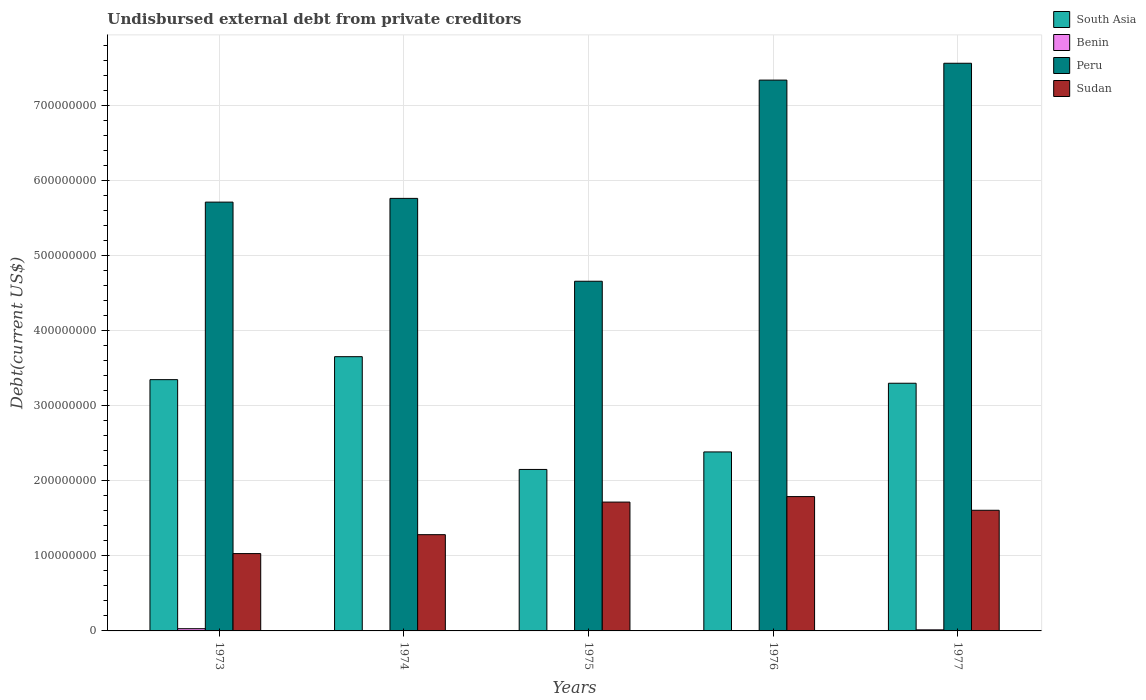How many different coloured bars are there?
Provide a succinct answer. 4. How many groups of bars are there?
Offer a very short reply. 5. What is the label of the 3rd group of bars from the left?
Ensure brevity in your answer.  1975. What is the total debt in Sudan in 1976?
Ensure brevity in your answer.  1.79e+08. Across all years, what is the maximum total debt in South Asia?
Provide a short and direct response. 3.65e+08. Across all years, what is the minimum total debt in Benin?
Provide a succinct answer. 4.31e+05. In which year was the total debt in South Asia maximum?
Make the answer very short. 1974. In which year was the total debt in Peru minimum?
Make the answer very short. 1975. What is the total total debt in Peru in the graph?
Make the answer very short. 3.10e+09. What is the difference between the total debt in Benin in 1974 and that in 1976?
Keep it short and to the point. 2000. What is the difference between the total debt in South Asia in 1975 and the total debt in Sudan in 1974?
Offer a very short reply. 8.69e+07. What is the average total debt in Benin per year?
Provide a short and direct response. 1.14e+06. In the year 1973, what is the difference between the total debt in Sudan and total debt in South Asia?
Provide a succinct answer. -2.32e+08. What is the ratio of the total debt in Sudan in 1973 to that in 1976?
Keep it short and to the point. 0.58. Is the difference between the total debt in Sudan in 1973 and 1974 greater than the difference between the total debt in South Asia in 1973 and 1974?
Offer a very short reply. Yes. What is the difference between the highest and the second highest total debt in Benin?
Provide a short and direct response. 1.53e+06. What is the difference between the highest and the lowest total debt in Benin?
Your response must be concise. 2.53e+06. In how many years, is the total debt in Sudan greater than the average total debt in Sudan taken over all years?
Give a very brief answer. 3. What does the 1st bar from the left in 1973 represents?
Give a very brief answer. South Asia. What does the 1st bar from the right in 1974 represents?
Provide a succinct answer. Sudan. Is it the case that in every year, the sum of the total debt in Sudan and total debt in South Asia is greater than the total debt in Peru?
Give a very brief answer. No. What is the difference between two consecutive major ticks on the Y-axis?
Offer a terse response. 1.00e+08. Are the values on the major ticks of Y-axis written in scientific E-notation?
Your answer should be compact. No. Does the graph contain grids?
Your response must be concise. Yes. Where does the legend appear in the graph?
Ensure brevity in your answer.  Top right. How are the legend labels stacked?
Offer a very short reply. Vertical. What is the title of the graph?
Make the answer very short. Undisbursed external debt from private creditors. Does "Zambia" appear as one of the legend labels in the graph?
Offer a terse response. No. What is the label or title of the Y-axis?
Offer a very short reply. Debt(current US$). What is the Debt(current US$) in South Asia in 1973?
Offer a terse response. 3.35e+08. What is the Debt(current US$) in Benin in 1973?
Offer a very short reply. 2.96e+06. What is the Debt(current US$) in Peru in 1973?
Your answer should be very brief. 5.71e+08. What is the Debt(current US$) in Sudan in 1973?
Ensure brevity in your answer.  1.03e+08. What is the Debt(current US$) of South Asia in 1974?
Offer a terse response. 3.65e+08. What is the Debt(current US$) of Benin in 1974?
Your answer should be very brief. 4.33e+05. What is the Debt(current US$) in Peru in 1974?
Your response must be concise. 5.76e+08. What is the Debt(current US$) in Sudan in 1974?
Provide a succinct answer. 1.28e+08. What is the Debt(current US$) in South Asia in 1975?
Offer a terse response. 2.15e+08. What is the Debt(current US$) of Benin in 1975?
Ensure brevity in your answer.  4.32e+05. What is the Debt(current US$) in Peru in 1975?
Your response must be concise. 4.66e+08. What is the Debt(current US$) of Sudan in 1975?
Offer a very short reply. 1.72e+08. What is the Debt(current US$) of South Asia in 1976?
Provide a short and direct response. 2.38e+08. What is the Debt(current US$) in Benin in 1976?
Provide a short and direct response. 4.31e+05. What is the Debt(current US$) in Peru in 1976?
Your answer should be very brief. 7.34e+08. What is the Debt(current US$) of Sudan in 1976?
Ensure brevity in your answer.  1.79e+08. What is the Debt(current US$) of South Asia in 1977?
Provide a short and direct response. 3.30e+08. What is the Debt(current US$) of Benin in 1977?
Your response must be concise. 1.43e+06. What is the Debt(current US$) of Peru in 1977?
Make the answer very short. 7.56e+08. What is the Debt(current US$) in Sudan in 1977?
Ensure brevity in your answer.  1.61e+08. Across all years, what is the maximum Debt(current US$) of South Asia?
Offer a very short reply. 3.65e+08. Across all years, what is the maximum Debt(current US$) of Benin?
Your response must be concise. 2.96e+06. Across all years, what is the maximum Debt(current US$) of Peru?
Make the answer very short. 7.56e+08. Across all years, what is the maximum Debt(current US$) in Sudan?
Keep it short and to the point. 1.79e+08. Across all years, what is the minimum Debt(current US$) of South Asia?
Offer a terse response. 2.15e+08. Across all years, what is the minimum Debt(current US$) of Benin?
Make the answer very short. 4.31e+05. Across all years, what is the minimum Debt(current US$) in Peru?
Ensure brevity in your answer.  4.66e+08. Across all years, what is the minimum Debt(current US$) in Sudan?
Ensure brevity in your answer.  1.03e+08. What is the total Debt(current US$) in South Asia in the graph?
Provide a succinct answer. 1.48e+09. What is the total Debt(current US$) in Benin in the graph?
Your answer should be compact. 5.69e+06. What is the total Debt(current US$) of Peru in the graph?
Your answer should be compact. 3.10e+09. What is the total Debt(current US$) of Sudan in the graph?
Ensure brevity in your answer.  7.43e+08. What is the difference between the Debt(current US$) of South Asia in 1973 and that in 1974?
Provide a short and direct response. -3.06e+07. What is the difference between the Debt(current US$) of Benin in 1973 and that in 1974?
Offer a very short reply. 2.52e+06. What is the difference between the Debt(current US$) in Peru in 1973 and that in 1974?
Offer a very short reply. -4.98e+06. What is the difference between the Debt(current US$) in Sudan in 1973 and that in 1974?
Provide a short and direct response. -2.52e+07. What is the difference between the Debt(current US$) of South Asia in 1973 and that in 1975?
Ensure brevity in your answer.  1.20e+08. What is the difference between the Debt(current US$) of Benin in 1973 and that in 1975?
Provide a short and direct response. 2.53e+06. What is the difference between the Debt(current US$) of Peru in 1973 and that in 1975?
Give a very brief answer. 1.05e+08. What is the difference between the Debt(current US$) in Sudan in 1973 and that in 1975?
Your response must be concise. -6.86e+07. What is the difference between the Debt(current US$) in South Asia in 1973 and that in 1976?
Offer a terse response. 9.63e+07. What is the difference between the Debt(current US$) of Benin in 1973 and that in 1976?
Give a very brief answer. 2.53e+06. What is the difference between the Debt(current US$) in Peru in 1973 and that in 1976?
Your response must be concise. -1.63e+08. What is the difference between the Debt(current US$) of Sudan in 1973 and that in 1976?
Offer a very short reply. -7.59e+07. What is the difference between the Debt(current US$) in South Asia in 1973 and that in 1977?
Make the answer very short. 4.78e+06. What is the difference between the Debt(current US$) of Benin in 1973 and that in 1977?
Your response must be concise. 1.53e+06. What is the difference between the Debt(current US$) in Peru in 1973 and that in 1977?
Keep it short and to the point. -1.85e+08. What is the difference between the Debt(current US$) of Sudan in 1973 and that in 1977?
Provide a succinct answer. -5.77e+07. What is the difference between the Debt(current US$) of South Asia in 1974 and that in 1975?
Ensure brevity in your answer.  1.50e+08. What is the difference between the Debt(current US$) in Peru in 1974 and that in 1975?
Provide a short and direct response. 1.10e+08. What is the difference between the Debt(current US$) of Sudan in 1974 and that in 1975?
Provide a short and direct response. -4.34e+07. What is the difference between the Debt(current US$) in South Asia in 1974 and that in 1976?
Offer a terse response. 1.27e+08. What is the difference between the Debt(current US$) in Benin in 1974 and that in 1976?
Your response must be concise. 2000. What is the difference between the Debt(current US$) in Peru in 1974 and that in 1976?
Provide a short and direct response. -1.58e+08. What is the difference between the Debt(current US$) of Sudan in 1974 and that in 1976?
Ensure brevity in your answer.  -5.07e+07. What is the difference between the Debt(current US$) in South Asia in 1974 and that in 1977?
Offer a terse response. 3.54e+07. What is the difference between the Debt(current US$) of Benin in 1974 and that in 1977?
Ensure brevity in your answer.  -9.99e+05. What is the difference between the Debt(current US$) in Peru in 1974 and that in 1977?
Offer a terse response. -1.80e+08. What is the difference between the Debt(current US$) in Sudan in 1974 and that in 1977?
Provide a succinct answer. -3.25e+07. What is the difference between the Debt(current US$) of South Asia in 1975 and that in 1976?
Make the answer very short. -2.33e+07. What is the difference between the Debt(current US$) of Benin in 1975 and that in 1976?
Make the answer very short. 1000. What is the difference between the Debt(current US$) in Peru in 1975 and that in 1976?
Keep it short and to the point. -2.68e+08. What is the difference between the Debt(current US$) of Sudan in 1975 and that in 1976?
Make the answer very short. -7.33e+06. What is the difference between the Debt(current US$) in South Asia in 1975 and that in 1977?
Your answer should be very brief. -1.15e+08. What is the difference between the Debt(current US$) in Peru in 1975 and that in 1977?
Offer a terse response. -2.90e+08. What is the difference between the Debt(current US$) in Sudan in 1975 and that in 1977?
Your response must be concise. 1.09e+07. What is the difference between the Debt(current US$) of South Asia in 1976 and that in 1977?
Make the answer very short. -9.15e+07. What is the difference between the Debt(current US$) of Benin in 1976 and that in 1977?
Your response must be concise. -1.00e+06. What is the difference between the Debt(current US$) of Peru in 1976 and that in 1977?
Your response must be concise. -2.24e+07. What is the difference between the Debt(current US$) of Sudan in 1976 and that in 1977?
Your answer should be compact. 1.82e+07. What is the difference between the Debt(current US$) of South Asia in 1973 and the Debt(current US$) of Benin in 1974?
Give a very brief answer. 3.34e+08. What is the difference between the Debt(current US$) of South Asia in 1973 and the Debt(current US$) of Peru in 1974?
Ensure brevity in your answer.  -2.42e+08. What is the difference between the Debt(current US$) in South Asia in 1973 and the Debt(current US$) in Sudan in 1974?
Offer a terse response. 2.07e+08. What is the difference between the Debt(current US$) in Benin in 1973 and the Debt(current US$) in Peru in 1974?
Offer a very short reply. -5.73e+08. What is the difference between the Debt(current US$) of Benin in 1973 and the Debt(current US$) of Sudan in 1974?
Keep it short and to the point. -1.25e+08. What is the difference between the Debt(current US$) of Peru in 1973 and the Debt(current US$) of Sudan in 1974?
Keep it short and to the point. 4.43e+08. What is the difference between the Debt(current US$) of South Asia in 1973 and the Debt(current US$) of Benin in 1975?
Ensure brevity in your answer.  3.34e+08. What is the difference between the Debt(current US$) in South Asia in 1973 and the Debt(current US$) in Peru in 1975?
Offer a terse response. -1.31e+08. What is the difference between the Debt(current US$) in South Asia in 1973 and the Debt(current US$) in Sudan in 1975?
Your response must be concise. 1.63e+08. What is the difference between the Debt(current US$) of Benin in 1973 and the Debt(current US$) of Peru in 1975?
Your response must be concise. -4.63e+08. What is the difference between the Debt(current US$) of Benin in 1973 and the Debt(current US$) of Sudan in 1975?
Provide a succinct answer. -1.69e+08. What is the difference between the Debt(current US$) of Peru in 1973 and the Debt(current US$) of Sudan in 1975?
Provide a succinct answer. 4.00e+08. What is the difference between the Debt(current US$) in South Asia in 1973 and the Debt(current US$) in Benin in 1976?
Provide a short and direct response. 3.34e+08. What is the difference between the Debt(current US$) in South Asia in 1973 and the Debt(current US$) in Peru in 1976?
Provide a short and direct response. -3.99e+08. What is the difference between the Debt(current US$) of South Asia in 1973 and the Debt(current US$) of Sudan in 1976?
Keep it short and to the point. 1.56e+08. What is the difference between the Debt(current US$) of Benin in 1973 and the Debt(current US$) of Peru in 1976?
Make the answer very short. -7.31e+08. What is the difference between the Debt(current US$) of Benin in 1973 and the Debt(current US$) of Sudan in 1976?
Offer a terse response. -1.76e+08. What is the difference between the Debt(current US$) of Peru in 1973 and the Debt(current US$) of Sudan in 1976?
Provide a succinct answer. 3.92e+08. What is the difference between the Debt(current US$) in South Asia in 1973 and the Debt(current US$) in Benin in 1977?
Offer a very short reply. 3.33e+08. What is the difference between the Debt(current US$) of South Asia in 1973 and the Debt(current US$) of Peru in 1977?
Give a very brief answer. -4.22e+08. What is the difference between the Debt(current US$) of South Asia in 1973 and the Debt(current US$) of Sudan in 1977?
Offer a terse response. 1.74e+08. What is the difference between the Debt(current US$) of Benin in 1973 and the Debt(current US$) of Peru in 1977?
Provide a succinct answer. -7.53e+08. What is the difference between the Debt(current US$) in Benin in 1973 and the Debt(current US$) in Sudan in 1977?
Your answer should be very brief. -1.58e+08. What is the difference between the Debt(current US$) of Peru in 1973 and the Debt(current US$) of Sudan in 1977?
Give a very brief answer. 4.11e+08. What is the difference between the Debt(current US$) in South Asia in 1974 and the Debt(current US$) in Benin in 1975?
Your answer should be very brief. 3.65e+08. What is the difference between the Debt(current US$) of South Asia in 1974 and the Debt(current US$) of Peru in 1975?
Offer a very short reply. -1.01e+08. What is the difference between the Debt(current US$) of South Asia in 1974 and the Debt(current US$) of Sudan in 1975?
Your answer should be very brief. 1.94e+08. What is the difference between the Debt(current US$) in Benin in 1974 and the Debt(current US$) in Peru in 1975?
Offer a terse response. -4.65e+08. What is the difference between the Debt(current US$) in Benin in 1974 and the Debt(current US$) in Sudan in 1975?
Your answer should be very brief. -1.71e+08. What is the difference between the Debt(current US$) of Peru in 1974 and the Debt(current US$) of Sudan in 1975?
Your response must be concise. 4.05e+08. What is the difference between the Debt(current US$) in South Asia in 1974 and the Debt(current US$) in Benin in 1976?
Offer a terse response. 3.65e+08. What is the difference between the Debt(current US$) of South Asia in 1974 and the Debt(current US$) of Peru in 1976?
Provide a short and direct response. -3.69e+08. What is the difference between the Debt(current US$) in South Asia in 1974 and the Debt(current US$) in Sudan in 1976?
Provide a succinct answer. 1.86e+08. What is the difference between the Debt(current US$) in Benin in 1974 and the Debt(current US$) in Peru in 1976?
Ensure brevity in your answer.  -7.33e+08. What is the difference between the Debt(current US$) in Benin in 1974 and the Debt(current US$) in Sudan in 1976?
Your answer should be compact. -1.79e+08. What is the difference between the Debt(current US$) of Peru in 1974 and the Debt(current US$) of Sudan in 1976?
Offer a very short reply. 3.97e+08. What is the difference between the Debt(current US$) in South Asia in 1974 and the Debt(current US$) in Benin in 1977?
Your answer should be compact. 3.64e+08. What is the difference between the Debt(current US$) in South Asia in 1974 and the Debt(current US$) in Peru in 1977?
Your answer should be compact. -3.91e+08. What is the difference between the Debt(current US$) in South Asia in 1974 and the Debt(current US$) in Sudan in 1977?
Provide a succinct answer. 2.05e+08. What is the difference between the Debt(current US$) of Benin in 1974 and the Debt(current US$) of Peru in 1977?
Make the answer very short. -7.56e+08. What is the difference between the Debt(current US$) in Benin in 1974 and the Debt(current US$) in Sudan in 1977?
Your answer should be compact. -1.60e+08. What is the difference between the Debt(current US$) in Peru in 1974 and the Debt(current US$) in Sudan in 1977?
Your answer should be very brief. 4.16e+08. What is the difference between the Debt(current US$) in South Asia in 1975 and the Debt(current US$) in Benin in 1976?
Your response must be concise. 2.15e+08. What is the difference between the Debt(current US$) in South Asia in 1975 and the Debt(current US$) in Peru in 1976?
Provide a succinct answer. -5.19e+08. What is the difference between the Debt(current US$) in South Asia in 1975 and the Debt(current US$) in Sudan in 1976?
Make the answer very short. 3.62e+07. What is the difference between the Debt(current US$) of Benin in 1975 and the Debt(current US$) of Peru in 1976?
Your response must be concise. -7.33e+08. What is the difference between the Debt(current US$) of Benin in 1975 and the Debt(current US$) of Sudan in 1976?
Offer a terse response. -1.79e+08. What is the difference between the Debt(current US$) in Peru in 1975 and the Debt(current US$) in Sudan in 1976?
Ensure brevity in your answer.  2.87e+08. What is the difference between the Debt(current US$) of South Asia in 1975 and the Debt(current US$) of Benin in 1977?
Give a very brief answer. 2.14e+08. What is the difference between the Debt(current US$) in South Asia in 1975 and the Debt(current US$) in Peru in 1977?
Offer a very short reply. -5.41e+08. What is the difference between the Debt(current US$) of South Asia in 1975 and the Debt(current US$) of Sudan in 1977?
Offer a very short reply. 5.44e+07. What is the difference between the Debt(current US$) in Benin in 1975 and the Debt(current US$) in Peru in 1977?
Ensure brevity in your answer.  -7.56e+08. What is the difference between the Debt(current US$) in Benin in 1975 and the Debt(current US$) in Sudan in 1977?
Provide a succinct answer. -1.60e+08. What is the difference between the Debt(current US$) of Peru in 1975 and the Debt(current US$) of Sudan in 1977?
Make the answer very short. 3.05e+08. What is the difference between the Debt(current US$) in South Asia in 1976 and the Debt(current US$) in Benin in 1977?
Make the answer very short. 2.37e+08. What is the difference between the Debt(current US$) of South Asia in 1976 and the Debt(current US$) of Peru in 1977?
Your answer should be compact. -5.18e+08. What is the difference between the Debt(current US$) of South Asia in 1976 and the Debt(current US$) of Sudan in 1977?
Make the answer very short. 7.77e+07. What is the difference between the Debt(current US$) of Benin in 1976 and the Debt(current US$) of Peru in 1977?
Keep it short and to the point. -7.56e+08. What is the difference between the Debt(current US$) of Benin in 1976 and the Debt(current US$) of Sudan in 1977?
Offer a terse response. -1.60e+08. What is the difference between the Debt(current US$) of Peru in 1976 and the Debt(current US$) of Sudan in 1977?
Give a very brief answer. 5.73e+08. What is the average Debt(current US$) of South Asia per year?
Give a very brief answer. 2.97e+08. What is the average Debt(current US$) of Benin per year?
Give a very brief answer. 1.14e+06. What is the average Debt(current US$) of Peru per year?
Your answer should be compact. 6.21e+08. What is the average Debt(current US$) in Sudan per year?
Offer a terse response. 1.49e+08. In the year 1973, what is the difference between the Debt(current US$) in South Asia and Debt(current US$) in Benin?
Your answer should be compact. 3.32e+08. In the year 1973, what is the difference between the Debt(current US$) of South Asia and Debt(current US$) of Peru?
Your answer should be compact. -2.37e+08. In the year 1973, what is the difference between the Debt(current US$) of South Asia and Debt(current US$) of Sudan?
Offer a very short reply. 2.32e+08. In the year 1973, what is the difference between the Debt(current US$) in Benin and Debt(current US$) in Peru?
Your answer should be compact. -5.68e+08. In the year 1973, what is the difference between the Debt(current US$) in Benin and Debt(current US$) in Sudan?
Provide a short and direct response. -1.00e+08. In the year 1973, what is the difference between the Debt(current US$) of Peru and Debt(current US$) of Sudan?
Your answer should be very brief. 4.68e+08. In the year 1974, what is the difference between the Debt(current US$) of South Asia and Debt(current US$) of Benin?
Ensure brevity in your answer.  3.65e+08. In the year 1974, what is the difference between the Debt(current US$) of South Asia and Debt(current US$) of Peru?
Keep it short and to the point. -2.11e+08. In the year 1974, what is the difference between the Debt(current US$) of South Asia and Debt(current US$) of Sudan?
Your answer should be very brief. 2.37e+08. In the year 1974, what is the difference between the Debt(current US$) in Benin and Debt(current US$) in Peru?
Your response must be concise. -5.76e+08. In the year 1974, what is the difference between the Debt(current US$) in Benin and Debt(current US$) in Sudan?
Make the answer very short. -1.28e+08. In the year 1974, what is the difference between the Debt(current US$) of Peru and Debt(current US$) of Sudan?
Make the answer very short. 4.48e+08. In the year 1975, what is the difference between the Debt(current US$) in South Asia and Debt(current US$) in Benin?
Ensure brevity in your answer.  2.15e+08. In the year 1975, what is the difference between the Debt(current US$) in South Asia and Debt(current US$) in Peru?
Provide a short and direct response. -2.51e+08. In the year 1975, what is the difference between the Debt(current US$) in South Asia and Debt(current US$) in Sudan?
Ensure brevity in your answer.  4.35e+07. In the year 1975, what is the difference between the Debt(current US$) of Benin and Debt(current US$) of Peru?
Your response must be concise. -4.65e+08. In the year 1975, what is the difference between the Debt(current US$) of Benin and Debt(current US$) of Sudan?
Provide a short and direct response. -1.71e+08. In the year 1975, what is the difference between the Debt(current US$) in Peru and Debt(current US$) in Sudan?
Offer a terse response. 2.94e+08. In the year 1976, what is the difference between the Debt(current US$) of South Asia and Debt(current US$) of Benin?
Provide a succinct answer. 2.38e+08. In the year 1976, what is the difference between the Debt(current US$) in South Asia and Debt(current US$) in Peru?
Offer a terse response. -4.95e+08. In the year 1976, what is the difference between the Debt(current US$) in South Asia and Debt(current US$) in Sudan?
Provide a succinct answer. 5.95e+07. In the year 1976, what is the difference between the Debt(current US$) in Benin and Debt(current US$) in Peru?
Offer a terse response. -7.33e+08. In the year 1976, what is the difference between the Debt(current US$) of Benin and Debt(current US$) of Sudan?
Your answer should be compact. -1.79e+08. In the year 1976, what is the difference between the Debt(current US$) of Peru and Debt(current US$) of Sudan?
Your answer should be compact. 5.55e+08. In the year 1977, what is the difference between the Debt(current US$) of South Asia and Debt(current US$) of Benin?
Ensure brevity in your answer.  3.29e+08. In the year 1977, what is the difference between the Debt(current US$) of South Asia and Debt(current US$) of Peru?
Give a very brief answer. -4.26e+08. In the year 1977, what is the difference between the Debt(current US$) in South Asia and Debt(current US$) in Sudan?
Your response must be concise. 1.69e+08. In the year 1977, what is the difference between the Debt(current US$) in Benin and Debt(current US$) in Peru?
Ensure brevity in your answer.  -7.55e+08. In the year 1977, what is the difference between the Debt(current US$) in Benin and Debt(current US$) in Sudan?
Keep it short and to the point. -1.59e+08. In the year 1977, what is the difference between the Debt(current US$) in Peru and Debt(current US$) in Sudan?
Offer a terse response. 5.96e+08. What is the ratio of the Debt(current US$) of South Asia in 1973 to that in 1974?
Provide a short and direct response. 0.92. What is the ratio of the Debt(current US$) of Benin in 1973 to that in 1974?
Your answer should be very brief. 6.83. What is the ratio of the Debt(current US$) in Peru in 1973 to that in 1974?
Make the answer very short. 0.99. What is the ratio of the Debt(current US$) of Sudan in 1973 to that in 1974?
Provide a short and direct response. 0.8. What is the ratio of the Debt(current US$) in South Asia in 1973 to that in 1975?
Make the answer very short. 1.56. What is the ratio of the Debt(current US$) in Benin in 1973 to that in 1975?
Keep it short and to the point. 6.85. What is the ratio of the Debt(current US$) in Peru in 1973 to that in 1975?
Provide a short and direct response. 1.23. What is the ratio of the Debt(current US$) of Sudan in 1973 to that in 1975?
Ensure brevity in your answer.  0.6. What is the ratio of the Debt(current US$) of South Asia in 1973 to that in 1976?
Offer a terse response. 1.4. What is the ratio of the Debt(current US$) of Benin in 1973 to that in 1976?
Provide a succinct answer. 6.86. What is the ratio of the Debt(current US$) of Peru in 1973 to that in 1976?
Offer a very short reply. 0.78. What is the ratio of the Debt(current US$) of Sudan in 1973 to that in 1976?
Your response must be concise. 0.58. What is the ratio of the Debt(current US$) of South Asia in 1973 to that in 1977?
Your answer should be very brief. 1.01. What is the ratio of the Debt(current US$) of Benin in 1973 to that in 1977?
Your answer should be compact. 2.07. What is the ratio of the Debt(current US$) of Peru in 1973 to that in 1977?
Your response must be concise. 0.76. What is the ratio of the Debt(current US$) in Sudan in 1973 to that in 1977?
Keep it short and to the point. 0.64. What is the ratio of the Debt(current US$) in South Asia in 1974 to that in 1975?
Keep it short and to the point. 1.7. What is the ratio of the Debt(current US$) in Benin in 1974 to that in 1975?
Give a very brief answer. 1. What is the ratio of the Debt(current US$) of Peru in 1974 to that in 1975?
Provide a succinct answer. 1.24. What is the ratio of the Debt(current US$) of Sudan in 1974 to that in 1975?
Offer a very short reply. 0.75. What is the ratio of the Debt(current US$) in South Asia in 1974 to that in 1976?
Offer a very short reply. 1.53. What is the ratio of the Debt(current US$) of Peru in 1974 to that in 1976?
Give a very brief answer. 0.79. What is the ratio of the Debt(current US$) in Sudan in 1974 to that in 1976?
Make the answer very short. 0.72. What is the ratio of the Debt(current US$) of South Asia in 1974 to that in 1977?
Provide a short and direct response. 1.11. What is the ratio of the Debt(current US$) of Benin in 1974 to that in 1977?
Give a very brief answer. 0.3. What is the ratio of the Debt(current US$) in Peru in 1974 to that in 1977?
Provide a succinct answer. 0.76. What is the ratio of the Debt(current US$) of Sudan in 1974 to that in 1977?
Make the answer very short. 0.8. What is the ratio of the Debt(current US$) of South Asia in 1975 to that in 1976?
Your response must be concise. 0.9. What is the ratio of the Debt(current US$) of Benin in 1975 to that in 1976?
Keep it short and to the point. 1. What is the ratio of the Debt(current US$) of Peru in 1975 to that in 1976?
Your response must be concise. 0.63. What is the ratio of the Debt(current US$) of South Asia in 1975 to that in 1977?
Offer a very short reply. 0.65. What is the ratio of the Debt(current US$) of Benin in 1975 to that in 1977?
Your response must be concise. 0.3. What is the ratio of the Debt(current US$) in Peru in 1975 to that in 1977?
Your answer should be compact. 0.62. What is the ratio of the Debt(current US$) of Sudan in 1975 to that in 1977?
Keep it short and to the point. 1.07. What is the ratio of the Debt(current US$) of South Asia in 1976 to that in 1977?
Provide a succinct answer. 0.72. What is the ratio of the Debt(current US$) of Benin in 1976 to that in 1977?
Your answer should be compact. 0.3. What is the ratio of the Debt(current US$) in Peru in 1976 to that in 1977?
Your response must be concise. 0.97. What is the ratio of the Debt(current US$) of Sudan in 1976 to that in 1977?
Your answer should be compact. 1.11. What is the difference between the highest and the second highest Debt(current US$) of South Asia?
Offer a terse response. 3.06e+07. What is the difference between the highest and the second highest Debt(current US$) of Benin?
Keep it short and to the point. 1.53e+06. What is the difference between the highest and the second highest Debt(current US$) in Peru?
Your answer should be very brief. 2.24e+07. What is the difference between the highest and the second highest Debt(current US$) in Sudan?
Give a very brief answer. 7.33e+06. What is the difference between the highest and the lowest Debt(current US$) in South Asia?
Your answer should be compact. 1.50e+08. What is the difference between the highest and the lowest Debt(current US$) in Benin?
Provide a succinct answer. 2.53e+06. What is the difference between the highest and the lowest Debt(current US$) in Peru?
Provide a succinct answer. 2.90e+08. What is the difference between the highest and the lowest Debt(current US$) of Sudan?
Ensure brevity in your answer.  7.59e+07. 